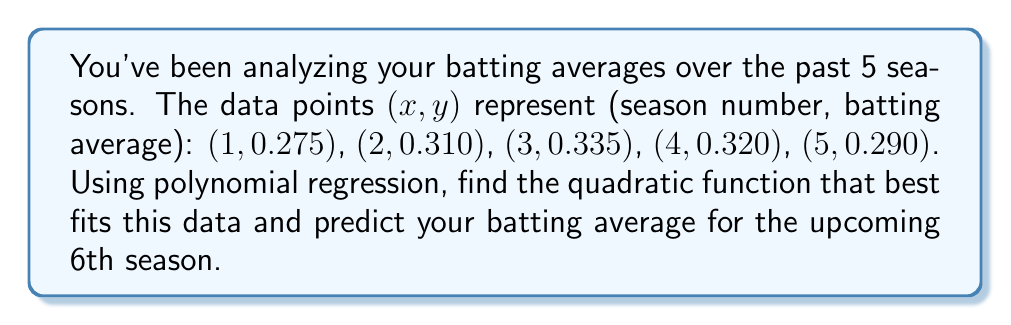Provide a solution to this math problem. 1. We need to find a quadratic function in the form $y = ax^2 + bx + c$ that best fits the given data.

2. To find the coefficients a, b, and c, we'll use the method of least squares. This involves solving the following system of equations:

   $$\begin{cases}
   \sum y = an + b\sum x + c\sum x^2 \\
   \sum xy = a\sum x + b\sum x^2 + c\sum x^3 \\
   \sum x^2y = a\sum x^2 + b\sum x^3 + c\sum x^4
   \end{cases}$$

3. Calculate the required sums:
   $\sum x = 1 + 2 + 3 + 4 + 5 = 15$
   $\sum x^2 = 1 + 4 + 9 + 16 + 25 = 55$
   $\sum x^3 = 1 + 8 + 27 + 64 + 125 = 225$
   $\sum x^4 = 1 + 16 + 81 + 256 + 625 = 979$
   $\sum y = 0.275 + 0.310 + 0.335 + 0.320 + 0.290 = 1.530$
   $\sum xy = 0.275 + 0.620 + 1.005 + 1.280 + 1.450 = 4.630$
   $\sum x^2y = 0.275 + 1.240 + 3.015 + 5.120 + 7.250 = 16.900$

4. Substitute these values into the system of equations:

   $$\begin{cases}
   1.530 = 5a + 15b + 55c \\
   4.630 = 15a + 55b + 225c \\
   16.900 = 55a + 225b + 979c
   \end{cases}$$

5. Solve this system of equations (using a calculator or computer algebra system) to get:
   $a \approx -0.01325$
   $b \approx 0.09275$
   $c \approx 0.19550$

6. The quadratic function that best fits the data is:
   $y = -0.01325x^2 + 0.09275x + 0.19550$

7. To predict the batting average for the 6th season, substitute $x = 6$ into this equation:
   $y = -0.01325(6)^2 + 0.09275(6) + 0.19550 \approx 0.2765$
Answer: 0.2765 